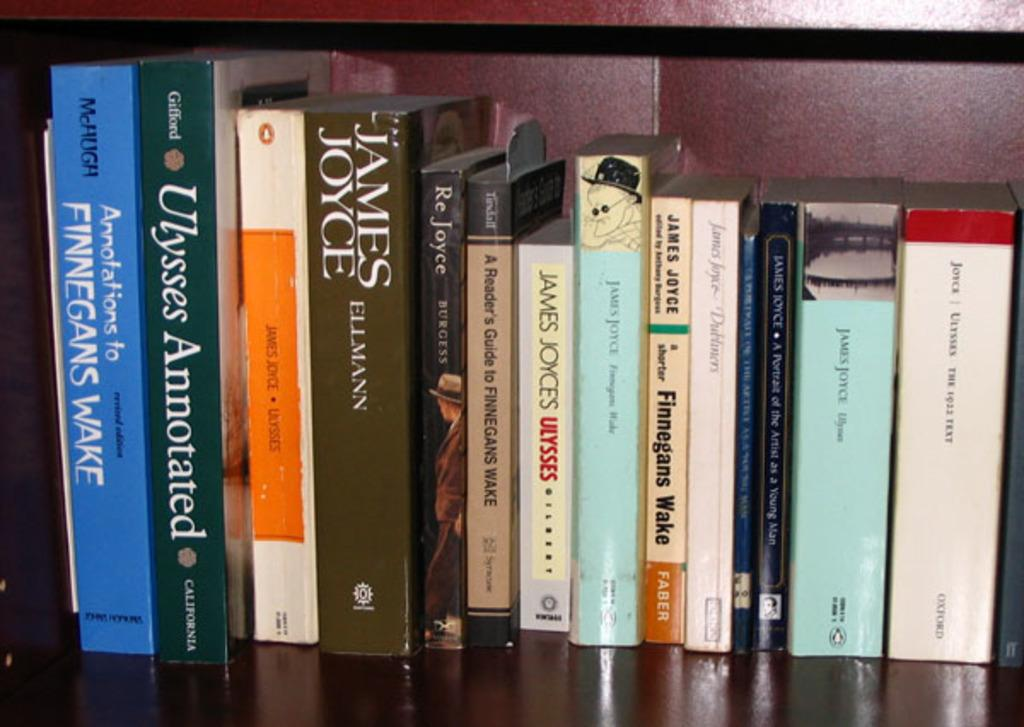Provide a one-sentence caption for the provided image. A collection of books with their spine facing out, one of them by James Joyce. 